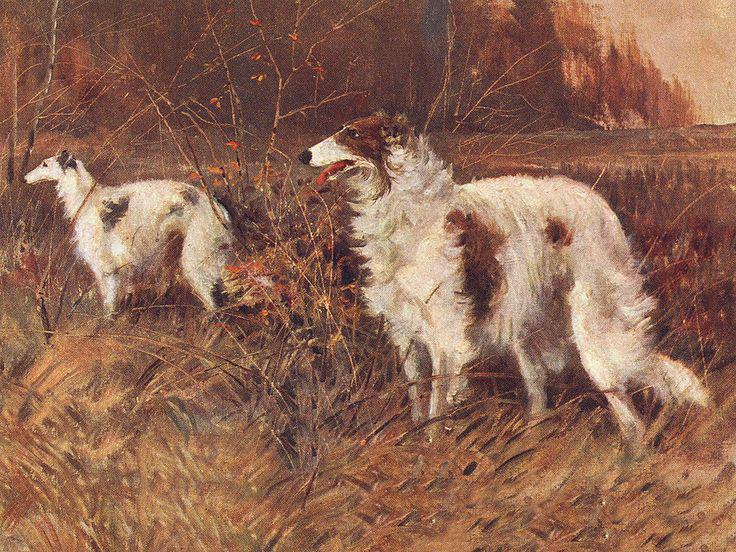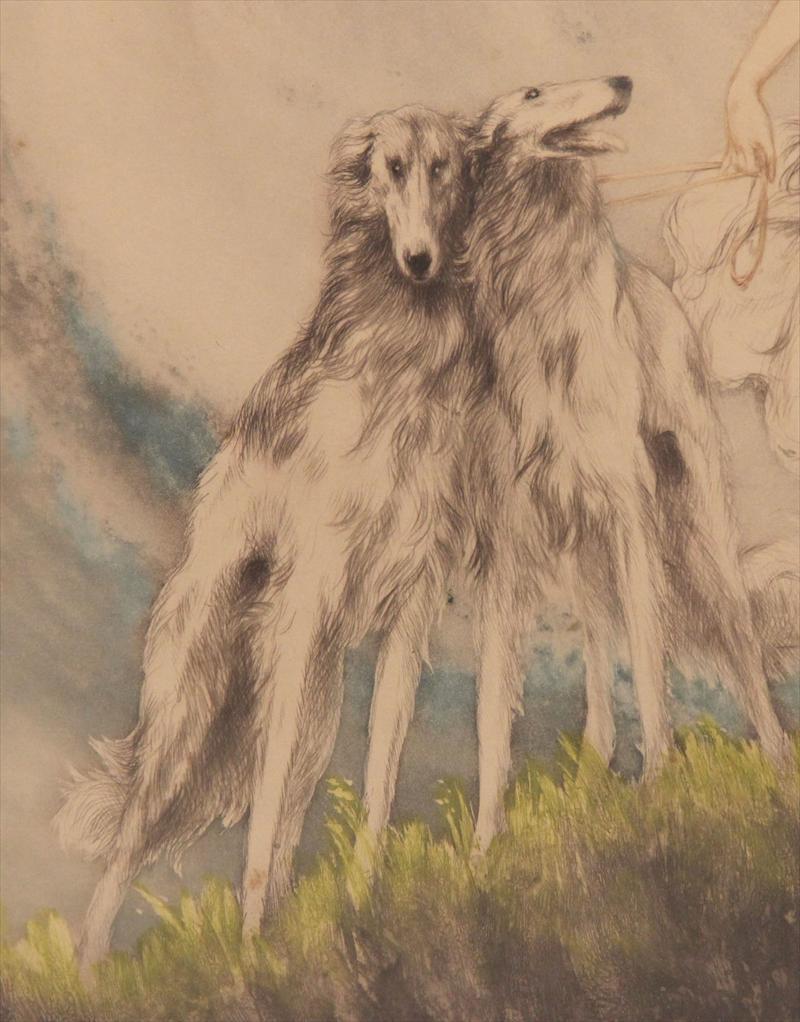The first image is the image on the left, the second image is the image on the right. For the images shown, is this caption "There is a woman sitting down with a dog next to her." true? Answer yes or no. No. The first image is the image on the left, the second image is the image on the right. For the images displayed, is the sentence "In at least one image there is a single female in a dress sit in a chair next to her white dog." factually correct? Answer yes or no. No. 